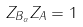Convert formula to latex. <formula><loc_0><loc_0><loc_500><loc_500>Z _ { B _ { \alpha } } Z _ { A } = 1</formula> 